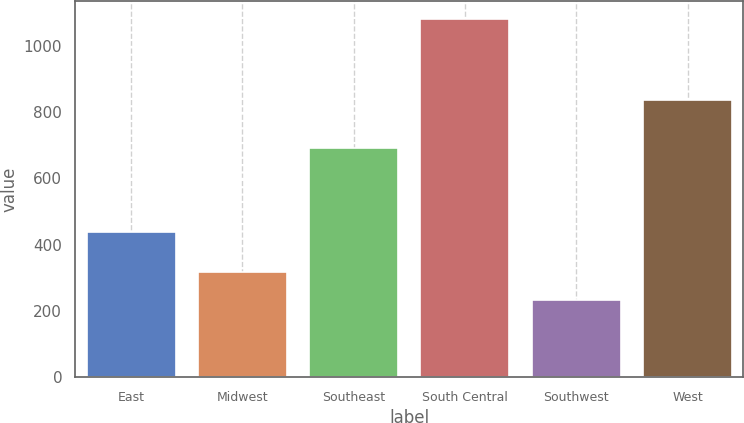Convert chart to OTSL. <chart><loc_0><loc_0><loc_500><loc_500><bar_chart><fcel>East<fcel>Midwest<fcel>Southeast<fcel>South Central<fcel>Southwest<fcel>West<nl><fcel>438.4<fcel>319.32<fcel>691.8<fcel>1080<fcel>234.8<fcel>835.8<nl></chart> 